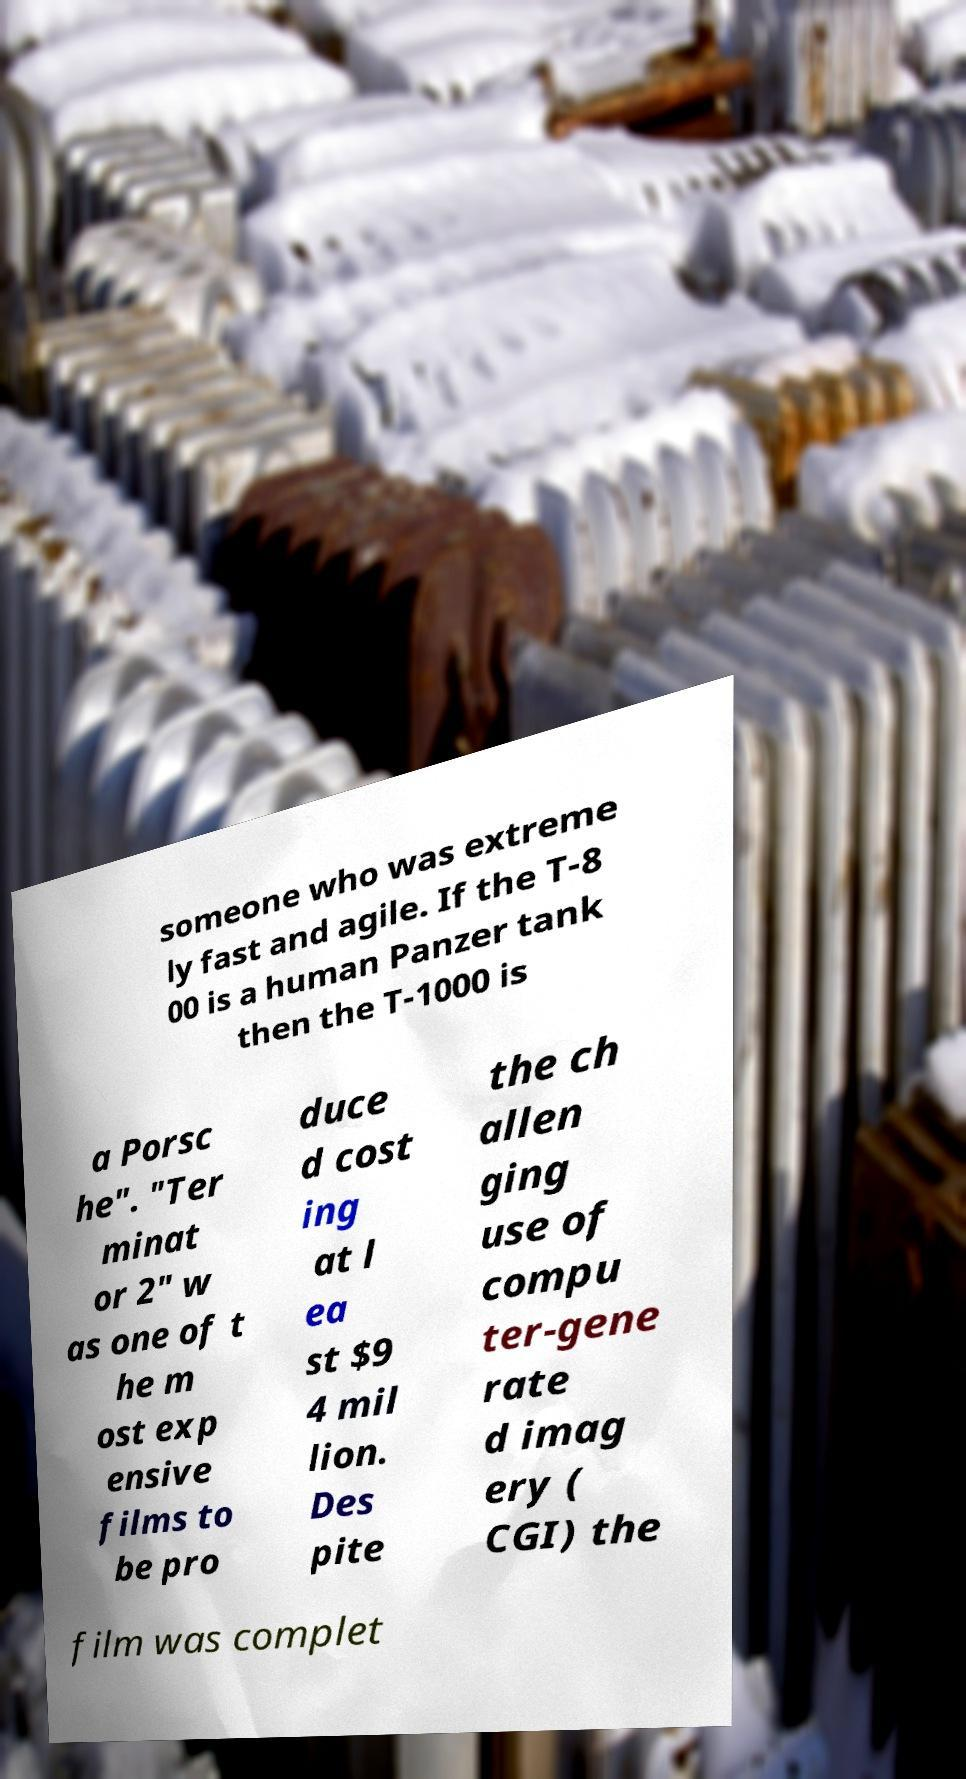Could you assist in decoding the text presented in this image and type it out clearly? someone who was extreme ly fast and agile. If the T-8 00 is a human Panzer tank then the T-1000 is a Porsc he". "Ter minat or 2" w as one of t he m ost exp ensive films to be pro duce d cost ing at l ea st $9 4 mil lion. Des pite the ch allen ging use of compu ter-gene rate d imag ery ( CGI) the film was complet 